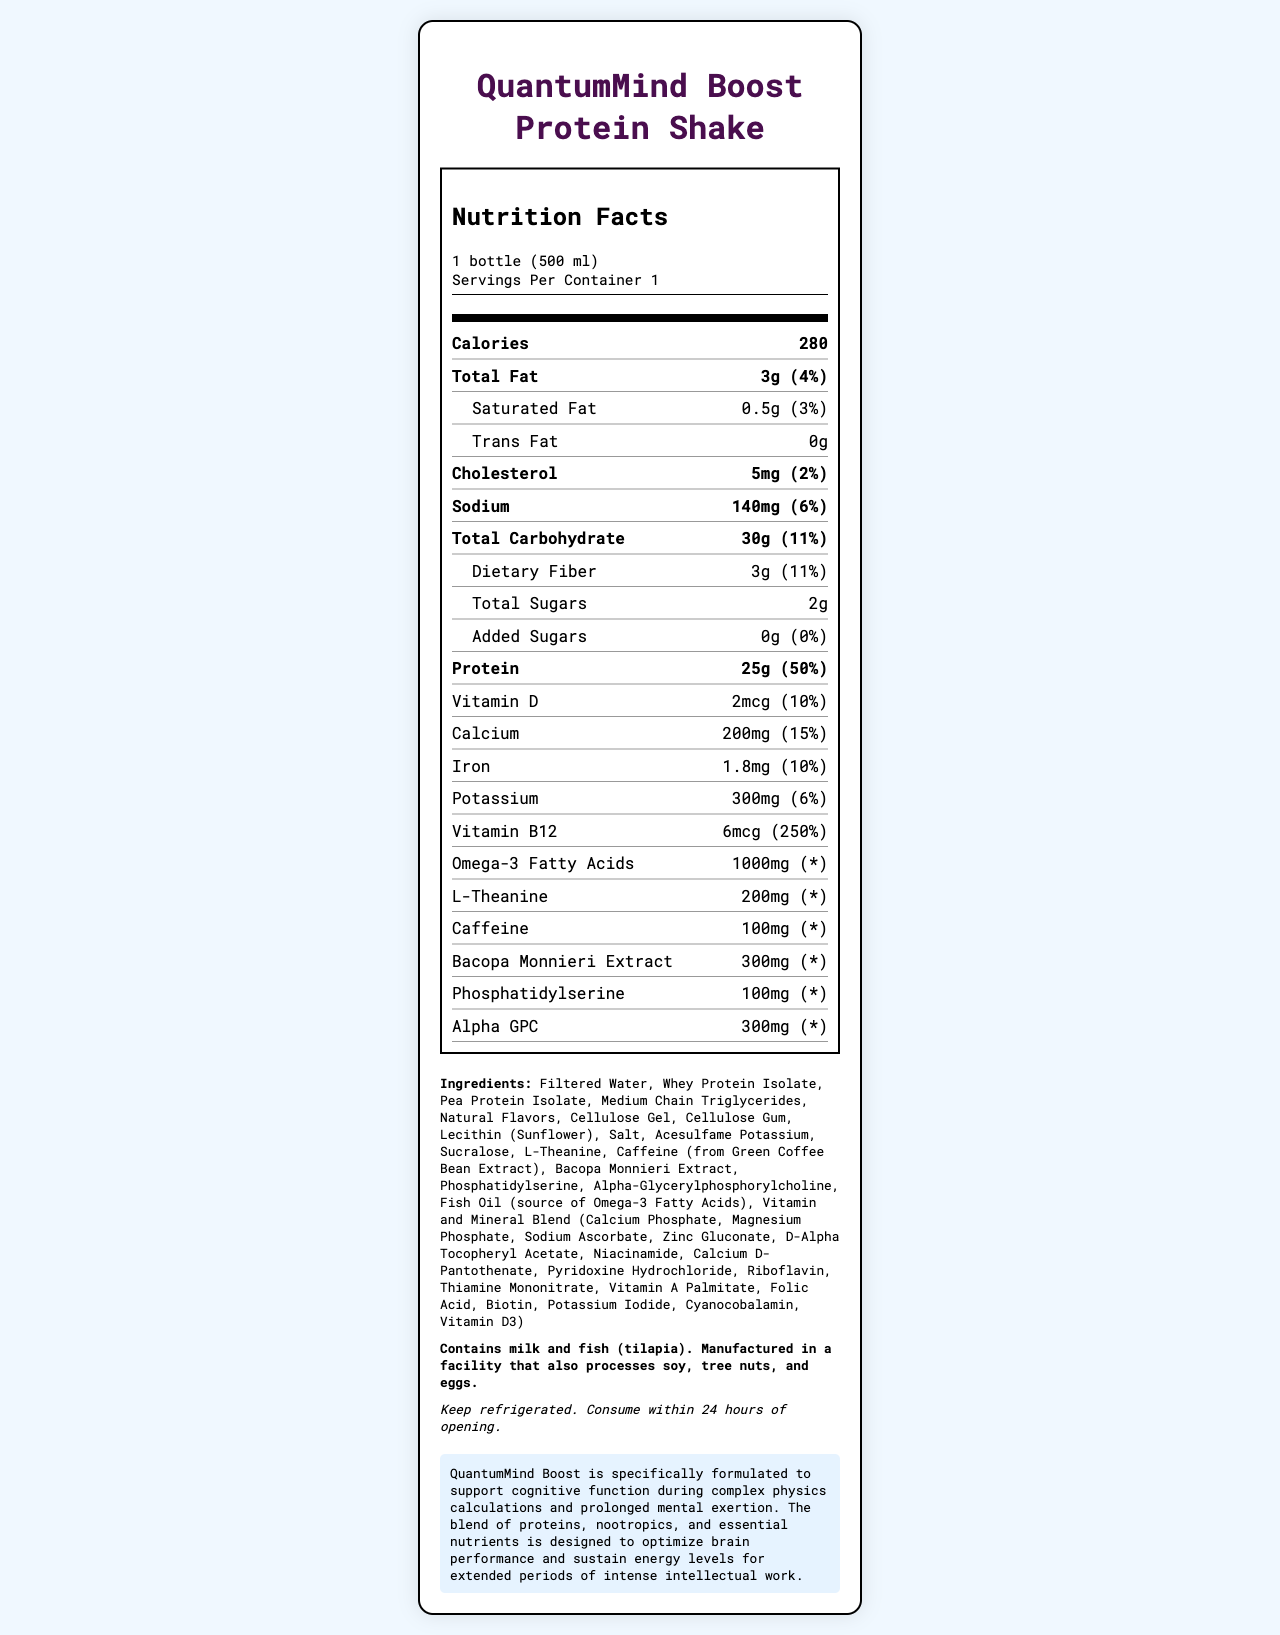What is the serving size of QuantumMind Boost Protein Shake? The serving size is listed at the top under the product name.
Answer: 1 bottle (500 ml) How many calories are in one serving of the protein shake? The calories are prominently mentioned in the "Nutrition Facts" section.
Answer: 280 How much protein does one serving of the shake contain? The protein content is listed in the "Nutrition Facts" section with its corresponding daily value percentage of 50%.
Answer: 25g What percentage of the daily value does the calcium content represent? The percentage of daily value for calcium is listed next to its amount in the "Nutrition Facts" label.
Answer: 15% List two nootropics included in the QuantumMind Boost Protein Shake. These ingredients are part of the shake's specialized blend, as listed in the "Nutrition Facts".
Answer: L-Theanine, Bacopa Monnieri Extract What is the total amount of sugars in one serving? Total sugars are clearly mentioned under the "Total Carbohydrate" section.
Answer: 2g How much caffeine is in one serving of the shake? A. 50mg B. 100mg C. 150mg The amount of caffeine per serving is listed under the specific nutrients.
Answer: B. 100mg Which vitamin has the highest daily value percentage in this shake? A. Vitamin D B. Iron C. Vitamin B12 D. Calcium The daily value for Vitamin B12 is 250%, the highest among the listed vitamins and minerals.
Answer: C. Vitamin B12 Is there any added sugar in QuantumMind Boost Protein Shake? The label indicates added sugars as 0g with 0% daily value, implying no added sugars.
Answer: No Should the protein shake be stored at room temperature? The storage instructions say to keep it refrigerated.
Answer: No Describe the main idea of the QuantumMind Boost Protein Shake. The document provides details on nutritional content, ingredients, and highlights its purpose to aid cognitive performance through a well-rounded composition.
Answer: QuantumMind Boost Protein Shake is a specially formulated drink designed to support cognitive function during complex tasks, containing a blend of proteins, nootropics, and essential nutrients to optimize brain performance and maintain energy levels. Can you determine the exact manufacturing process of this protein shake from the document? The document does not provide details about the manufacturing process, only the nutritional content, ingredients, and storage instructions.
Answer: Not enough information What allergens are present in this protein shake? The allergen information section specifies milk and fish as allergens.
Answer: Milk and fish (tilapia) What ingredient is the source of Omega-3 Fatty Acids in the shake? The ingredients list includes fish oil as the source of Omega-3 Fatty Acids.
Answer: Fish Oil 